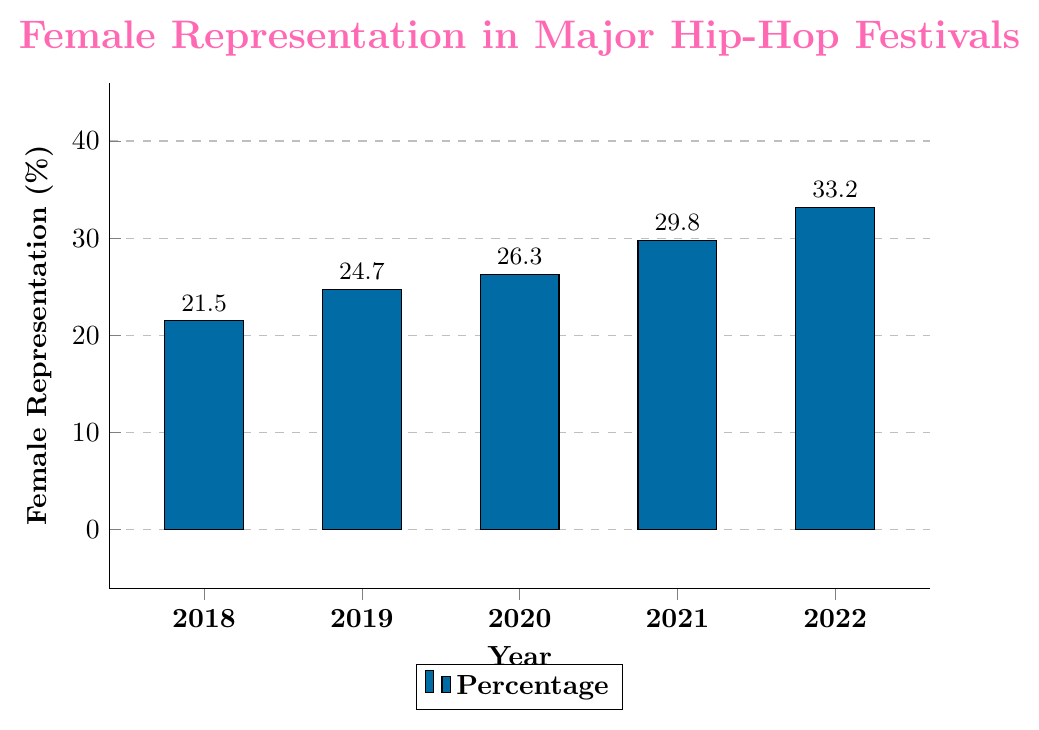What was the percentage of female representation in 2018? Look at the bar corresponding to 2018 and read off the height, which shows the percentage.
Answer: 21.5% What is the difference in female representation between 2018 and 2022? Identify the percentages for 2018 and 2022, then subtract the 2018 value from the 2022 value: 33.2% - 21.5% = 11.7%.
Answer: 11.7% Which year had the highest percentage of female representation? Examine the heights of all the bars and identify the tallest one, which corresponds to 2022.
Answer: 2022 What was the trend in female representation from 2018 to 2022—is it increasing, decreasing, or stable? Observe the direction of the changes in the bar heights from year to year: each subsequent bar is taller than the previous one, indicating an increasing trend.
Answer: Increasing What is the average percentage of female representation over the 5 years? Sum the percentages for each year and divide by 5: (21.5 + 24.7 + 26.3 + 29.8 + 33.2) / 5 = 27.1%.
Answer: 27.1% How much did the female representation increase from 2020 to 2021? Subtract the percentage of 2020 from the percentage of 2021: 29.8% - 26.3% = 3.5%.
Answer: 3.5% By how much did the female representation percentage change, on average, each year from 2018 to 2022? Find the total increase over the years and divide by the number of intervals: (33.2% - 21.5%) / 4 = 2.925%.
Answer: 2.925% In which year was the percentage of female representation closest to the average percentage over the 5 years? First calculate the average (27.1%), then find the year with the closest value by comparing the absolute differences. The percentage for 2020 is the closest:
Answer: 2020 Which two consecutive years had the largest increase in female representation? Calculate the differences between consecutive years and identify the largest: 2018-2019: 3.2%, 2019-2020: 1.6%, 2020-2021: 3.5%, 2021-2022: 3.4%. The largest increase is from 2020 to 2021.
Answer: 2020 to 2021 What percentage of female representation would be half of the total change from 2018 to 2022? First, find the total change: 33.2% - 21.5% = 11.7%. Then divide by 2: 11.7% / 2 = 5.85%.
Answer: 5.85% 